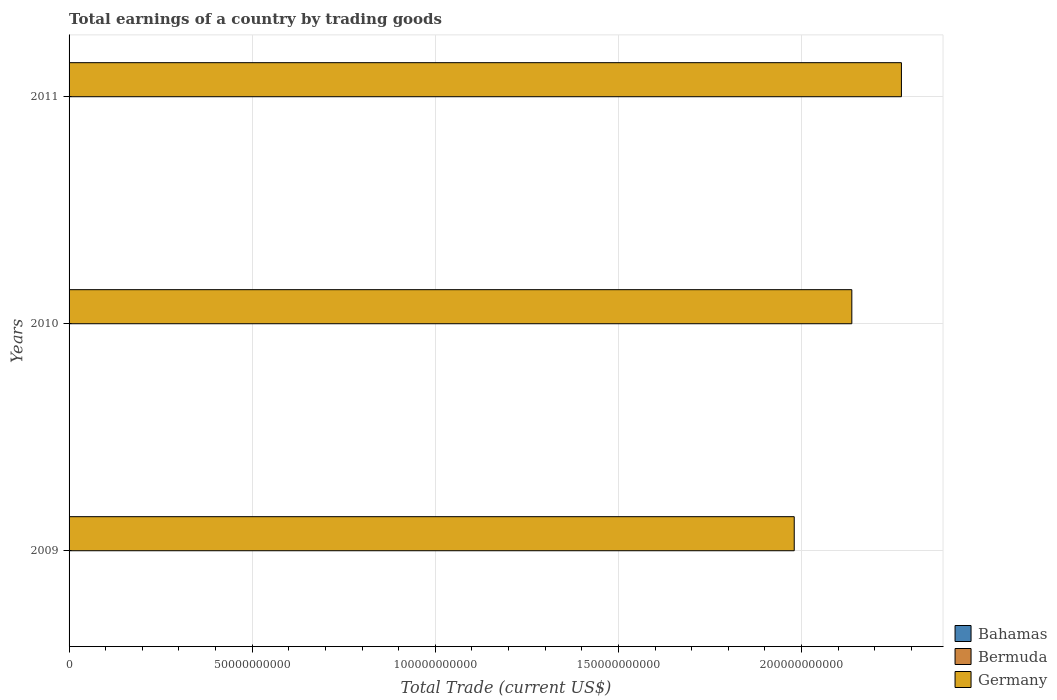How many different coloured bars are there?
Your response must be concise. 1. Are the number of bars on each tick of the Y-axis equal?
Offer a very short reply. Yes. How many bars are there on the 1st tick from the top?
Give a very brief answer. 1. In how many cases, is the number of bars for a given year not equal to the number of legend labels?
Provide a succinct answer. 3. Across all years, what is the maximum total earnings in Germany?
Provide a short and direct response. 2.27e+11. In which year was the total earnings in Germany maximum?
Offer a terse response. 2011. What is the total total earnings in Germany in the graph?
Give a very brief answer. 6.39e+11. What is the difference between the total earnings in Germany in 2010 and that in 2011?
Your answer should be compact. -1.35e+1. What is the average total earnings in Germany per year?
Offer a very short reply. 2.13e+11. In how many years, is the total earnings in Bahamas greater than 190000000000 US$?
Ensure brevity in your answer.  0. What is the ratio of the total earnings in Germany in 2009 to that in 2010?
Your answer should be compact. 0.93. Is the total earnings in Germany in 2010 less than that in 2011?
Provide a succinct answer. Yes. What is the difference between the highest and the lowest total earnings in Germany?
Make the answer very short. 2.93e+1. Is the sum of the total earnings in Germany in 2009 and 2010 greater than the maximum total earnings in Bahamas across all years?
Provide a succinct answer. Yes. Is it the case that in every year, the sum of the total earnings in Germany and total earnings in Bahamas is greater than the total earnings in Bermuda?
Provide a short and direct response. Yes. How many bars are there?
Your answer should be compact. 3. Are all the bars in the graph horizontal?
Give a very brief answer. Yes. How many years are there in the graph?
Provide a succinct answer. 3. What is the difference between two consecutive major ticks on the X-axis?
Give a very brief answer. 5.00e+1. Are the values on the major ticks of X-axis written in scientific E-notation?
Provide a short and direct response. No. Does the graph contain any zero values?
Give a very brief answer. Yes. Where does the legend appear in the graph?
Ensure brevity in your answer.  Bottom right. How many legend labels are there?
Your response must be concise. 3. How are the legend labels stacked?
Offer a very short reply. Vertical. What is the title of the graph?
Make the answer very short. Total earnings of a country by trading goods. What is the label or title of the X-axis?
Your response must be concise. Total Trade (current US$). What is the label or title of the Y-axis?
Keep it short and to the point. Years. What is the Total Trade (current US$) in Bahamas in 2009?
Offer a terse response. 0. What is the Total Trade (current US$) of Germany in 2009?
Your answer should be very brief. 1.98e+11. What is the Total Trade (current US$) in Bahamas in 2010?
Give a very brief answer. 0. What is the Total Trade (current US$) of Bermuda in 2010?
Ensure brevity in your answer.  0. What is the Total Trade (current US$) of Germany in 2010?
Give a very brief answer. 2.14e+11. What is the Total Trade (current US$) of Bahamas in 2011?
Provide a succinct answer. 0. What is the Total Trade (current US$) of Germany in 2011?
Provide a short and direct response. 2.27e+11. Across all years, what is the maximum Total Trade (current US$) in Germany?
Provide a short and direct response. 2.27e+11. Across all years, what is the minimum Total Trade (current US$) of Germany?
Your answer should be very brief. 1.98e+11. What is the total Total Trade (current US$) in Bermuda in the graph?
Your answer should be very brief. 0. What is the total Total Trade (current US$) of Germany in the graph?
Provide a short and direct response. 6.39e+11. What is the difference between the Total Trade (current US$) in Germany in 2009 and that in 2010?
Keep it short and to the point. -1.57e+1. What is the difference between the Total Trade (current US$) in Germany in 2009 and that in 2011?
Ensure brevity in your answer.  -2.93e+1. What is the difference between the Total Trade (current US$) in Germany in 2010 and that in 2011?
Give a very brief answer. -1.35e+1. What is the average Total Trade (current US$) in Bahamas per year?
Offer a very short reply. 0. What is the average Total Trade (current US$) of Bermuda per year?
Provide a succinct answer. 0. What is the average Total Trade (current US$) of Germany per year?
Offer a terse response. 2.13e+11. What is the ratio of the Total Trade (current US$) of Germany in 2009 to that in 2010?
Give a very brief answer. 0.93. What is the ratio of the Total Trade (current US$) of Germany in 2009 to that in 2011?
Offer a very short reply. 0.87. What is the ratio of the Total Trade (current US$) of Germany in 2010 to that in 2011?
Ensure brevity in your answer.  0.94. What is the difference between the highest and the second highest Total Trade (current US$) of Germany?
Make the answer very short. 1.35e+1. What is the difference between the highest and the lowest Total Trade (current US$) in Germany?
Offer a terse response. 2.93e+1. 